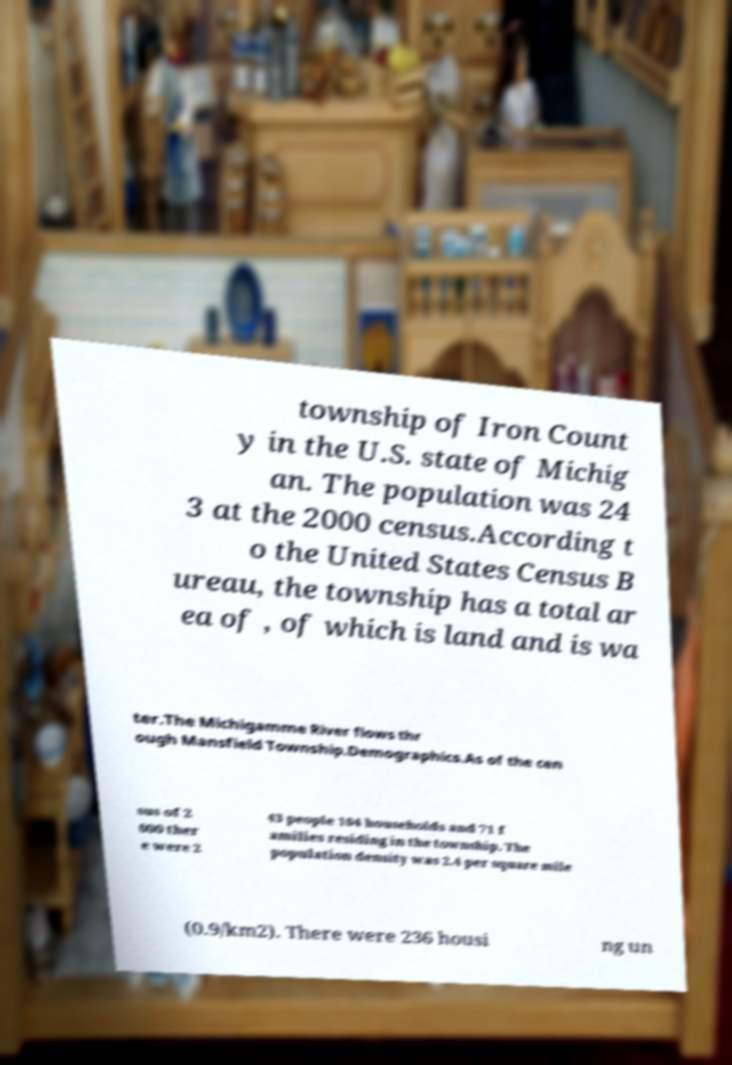Could you assist in decoding the text presented in this image and type it out clearly? township of Iron Count y in the U.S. state of Michig an. The population was 24 3 at the 2000 census.According t o the United States Census B ureau, the township has a total ar ea of , of which is land and is wa ter.The Michigamme River flows thr ough Mansfield Township.Demographics.As of the cen sus of 2 000 ther e were 2 43 people 104 households and 71 f amilies residing in the township. The population density was 2.4 per square mile (0.9/km2). There were 236 housi ng un 